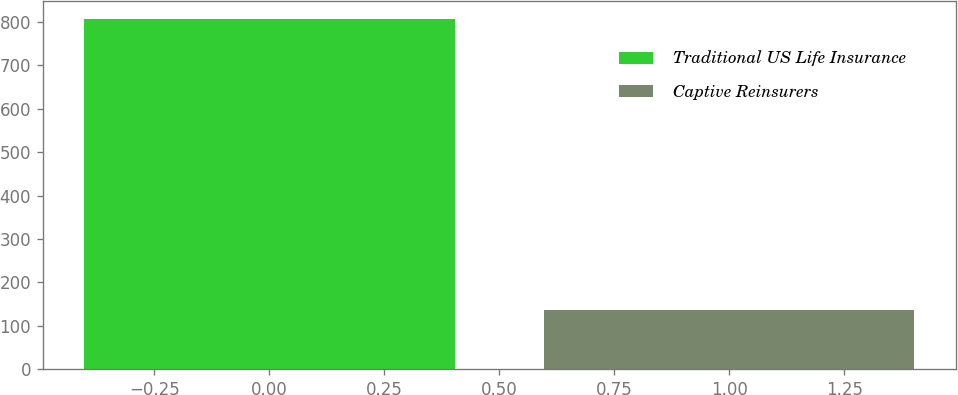<chart> <loc_0><loc_0><loc_500><loc_500><bar_chart><fcel>Traditional US Life Insurance<fcel>Captive Reinsurers<nl><fcel>807.4<fcel>137.1<nl></chart> 